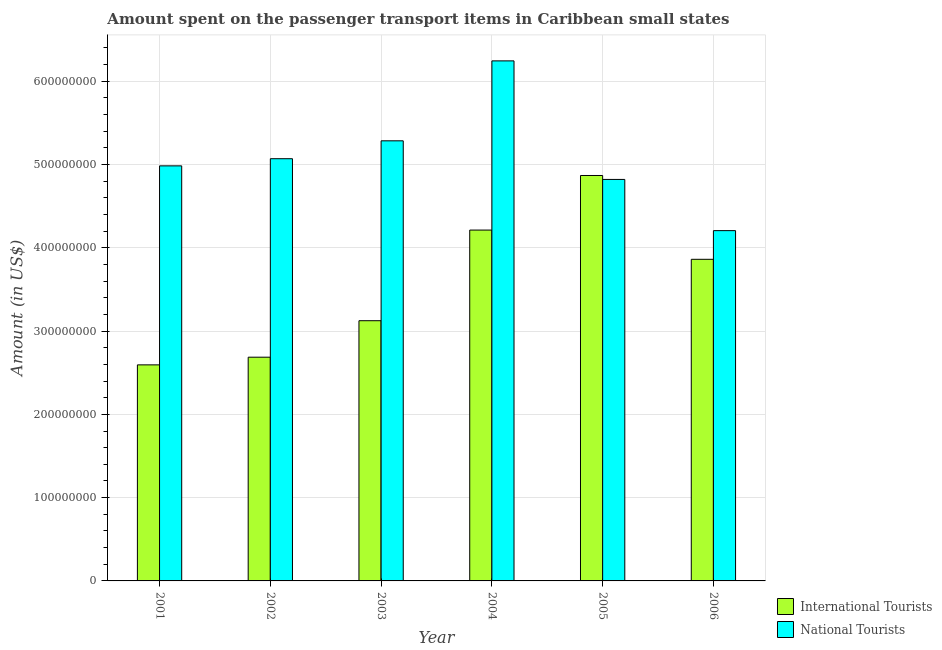Are the number of bars per tick equal to the number of legend labels?
Your answer should be compact. Yes. How many bars are there on the 6th tick from the right?
Give a very brief answer. 2. What is the label of the 6th group of bars from the left?
Provide a short and direct response. 2006. In how many cases, is the number of bars for a given year not equal to the number of legend labels?
Offer a terse response. 0. What is the amount spent on transport items of international tourists in 2005?
Make the answer very short. 4.87e+08. Across all years, what is the maximum amount spent on transport items of national tourists?
Provide a succinct answer. 6.25e+08. Across all years, what is the minimum amount spent on transport items of international tourists?
Your answer should be very brief. 2.59e+08. In which year was the amount spent on transport items of national tourists minimum?
Make the answer very short. 2006. What is the total amount spent on transport items of international tourists in the graph?
Offer a terse response. 2.14e+09. What is the difference between the amount spent on transport items of national tourists in 2001 and that in 2003?
Provide a succinct answer. -3.01e+07. What is the difference between the amount spent on transport items of international tourists in 2003 and the amount spent on transport items of national tourists in 2005?
Offer a terse response. -1.74e+08. What is the average amount spent on transport items of national tourists per year?
Offer a very short reply. 5.10e+08. In the year 2006, what is the difference between the amount spent on transport items of national tourists and amount spent on transport items of international tourists?
Make the answer very short. 0. What is the ratio of the amount spent on transport items of international tourists in 2002 to that in 2005?
Ensure brevity in your answer.  0.55. Is the difference between the amount spent on transport items of international tourists in 2003 and 2005 greater than the difference between the amount spent on transport items of national tourists in 2003 and 2005?
Offer a terse response. No. What is the difference between the highest and the second highest amount spent on transport items of national tourists?
Provide a short and direct response. 9.60e+07. What is the difference between the highest and the lowest amount spent on transport items of national tourists?
Ensure brevity in your answer.  2.04e+08. Is the sum of the amount spent on transport items of international tourists in 2001 and 2006 greater than the maximum amount spent on transport items of national tourists across all years?
Keep it short and to the point. Yes. What does the 2nd bar from the left in 2004 represents?
Provide a short and direct response. National Tourists. What does the 2nd bar from the right in 2003 represents?
Provide a succinct answer. International Tourists. How many bars are there?
Your response must be concise. 12. Are all the bars in the graph horizontal?
Your answer should be very brief. No. What is the difference between two consecutive major ticks on the Y-axis?
Your answer should be compact. 1.00e+08. Does the graph contain any zero values?
Provide a succinct answer. No. Where does the legend appear in the graph?
Offer a terse response. Bottom right. What is the title of the graph?
Offer a very short reply. Amount spent on the passenger transport items in Caribbean small states. What is the label or title of the X-axis?
Give a very brief answer. Year. What is the Amount (in US$) of International Tourists in 2001?
Offer a very short reply. 2.59e+08. What is the Amount (in US$) in National Tourists in 2001?
Offer a terse response. 4.98e+08. What is the Amount (in US$) of International Tourists in 2002?
Offer a terse response. 2.69e+08. What is the Amount (in US$) of National Tourists in 2002?
Ensure brevity in your answer.  5.07e+08. What is the Amount (in US$) of International Tourists in 2003?
Your answer should be very brief. 3.12e+08. What is the Amount (in US$) of National Tourists in 2003?
Give a very brief answer. 5.29e+08. What is the Amount (in US$) of International Tourists in 2004?
Keep it short and to the point. 4.21e+08. What is the Amount (in US$) of National Tourists in 2004?
Offer a terse response. 6.25e+08. What is the Amount (in US$) in International Tourists in 2005?
Your response must be concise. 4.87e+08. What is the Amount (in US$) in National Tourists in 2005?
Offer a very short reply. 4.82e+08. What is the Amount (in US$) in International Tourists in 2006?
Give a very brief answer. 3.86e+08. What is the Amount (in US$) in National Tourists in 2006?
Your answer should be very brief. 4.21e+08. Across all years, what is the maximum Amount (in US$) of International Tourists?
Your answer should be compact. 4.87e+08. Across all years, what is the maximum Amount (in US$) of National Tourists?
Make the answer very short. 6.25e+08. Across all years, what is the minimum Amount (in US$) in International Tourists?
Offer a terse response. 2.59e+08. Across all years, what is the minimum Amount (in US$) of National Tourists?
Ensure brevity in your answer.  4.21e+08. What is the total Amount (in US$) of International Tourists in the graph?
Offer a terse response. 2.14e+09. What is the total Amount (in US$) of National Tourists in the graph?
Your answer should be compact. 3.06e+09. What is the difference between the Amount (in US$) in International Tourists in 2001 and that in 2002?
Offer a very short reply. -9.22e+06. What is the difference between the Amount (in US$) of National Tourists in 2001 and that in 2002?
Your answer should be very brief. -8.59e+06. What is the difference between the Amount (in US$) of International Tourists in 2001 and that in 2003?
Make the answer very short. -5.30e+07. What is the difference between the Amount (in US$) in National Tourists in 2001 and that in 2003?
Make the answer very short. -3.01e+07. What is the difference between the Amount (in US$) of International Tourists in 2001 and that in 2004?
Your answer should be compact. -1.62e+08. What is the difference between the Amount (in US$) of National Tourists in 2001 and that in 2004?
Your answer should be very brief. -1.26e+08. What is the difference between the Amount (in US$) of International Tourists in 2001 and that in 2005?
Your response must be concise. -2.27e+08. What is the difference between the Amount (in US$) in National Tourists in 2001 and that in 2005?
Your answer should be compact. 1.63e+07. What is the difference between the Amount (in US$) of International Tourists in 2001 and that in 2006?
Give a very brief answer. -1.27e+08. What is the difference between the Amount (in US$) of National Tourists in 2001 and that in 2006?
Your response must be concise. 7.78e+07. What is the difference between the Amount (in US$) of International Tourists in 2002 and that in 2003?
Provide a succinct answer. -4.38e+07. What is the difference between the Amount (in US$) of National Tourists in 2002 and that in 2003?
Provide a short and direct response. -2.15e+07. What is the difference between the Amount (in US$) in International Tourists in 2002 and that in 2004?
Give a very brief answer. -1.53e+08. What is the difference between the Amount (in US$) in National Tourists in 2002 and that in 2004?
Your answer should be compact. -1.17e+08. What is the difference between the Amount (in US$) in International Tourists in 2002 and that in 2005?
Provide a succinct answer. -2.18e+08. What is the difference between the Amount (in US$) in National Tourists in 2002 and that in 2005?
Give a very brief answer. 2.49e+07. What is the difference between the Amount (in US$) of International Tourists in 2002 and that in 2006?
Your answer should be very brief. -1.18e+08. What is the difference between the Amount (in US$) of National Tourists in 2002 and that in 2006?
Give a very brief answer. 8.64e+07. What is the difference between the Amount (in US$) in International Tourists in 2003 and that in 2004?
Offer a terse response. -1.09e+08. What is the difference between the Amount (in US$) of National Tourists in 2003 and that in 2004?
Offer a very short reply. -9.60e+07. What is the difference between the Amount (in US$) in International Tourists in 2003 and that in 2005?
Provide a short and direct response. -1.74e+08. What is the difference between the Amount (in US$) in National Tourists in 2003 and that in 2005?
Your answer should be compact. 4.64e+07. What is the difference between the Amount (in US$) in International Tourists in 2003 and that in 2006?
Your answer should be very brief. -7.37e+07. What is the difference between the Amount (in US$) in National Tourists in 2003 and that in 2006?
Give a very brief answer. 1.08e+08. What is the difference between the Amount (in US$) in International Tourists in 2004 and that in 2005?
Your answer should be very brief. -6.55e+07. What is the difference between the Amount (in US$) in National Tourists in 2004 and that in 2005?
Provide a succinct answer. 1.42e+08. What is the difference between the Amount (in US$) of International Tourists in 2004 and that in 2006?
Keep it short and to the point. 3.51e+07. What is the difference between the Amount (in US$) of National Tourists in 2004 and that in 2006?
Provide a short and direct response. 2.04e+08. What is the difference between the Amount (in US$) in International Tourists in 2005 and that in 2006?
Provide a short and direct response. 1.01e+08. What is the difference between the Amount (in US$) in National Tourists in 2005 and that in 2006?
Make the answer very short. 6.15e+07. What is the difference between the Amount (in US$) of International Tourists in 2001 and the Amount (in US$) of National Tourists in 2002?
Provide a short and direct response. -2.48e+08. What is the difference between the Amount (in US$) of International Tourists in 2001 and the Amount (in US$) of National Tourists in 2003?
Your answer should be compact. -2.69e+08. What is the difference between the Amount (in US$) of International Tourists in 2001 and the Amount (in US$) of National Tourists in 2004?
Make the answer very short. -3.65e+08. What is the difference between the Amount (in US$) of International Tourists in 2001 and the Amount (in US$) of National Tourists in 2005?
Your answer should be compact. -2.23e+08. What is the difference between the Amount (in US$) in International Tourists in 2001 and the Amount (in US$) in National Tourists in 2006?
Your response must be concise. -1.61e+08. What is the difference between the Amount (in US$) in International Tourists in 2002 and the Amount (in US$) in National Tourists in 2003?
Offer a very short reply. -2.60e+08. What is the difference between the Amount (in US$) in International Tourists in 2002 and the Amount (in US$) in National Tourists in 2004?
Offer a terse response. -3.56e+08. What is the difference between the Amount (in US$) of International Tourists in 2002 and the Amount (in US$) of National Tourists in 2005?
Keep it short and to the point. -2.13e+08. What is the difference between the Amount (in US$) in International Tourists in 2002 and the Amount (in US$) in National Tourists in 2006?
Give a very brief answer. -1.52e+08. What is the difference between the Amount (in US$) of International Tourists in 2003 and the Amount (in US$) of National Tourists in 2004?
Provide a short and direct response. -3.12e+08. What is the difference between the Amount (in US$) of International Tourists in 2003 and the Amount (in US$) of National Tourists in 2005?
Offer a very short reply. -1.70e+08. What is the difference between the Amount (in US$) of International Tourists in 2003 and the Amount (in US$) of National Tourists in 2006?
Give a very brief answer. -1.08e+08. What is the difference between the Amount (in US$) in International Tourists in 2004 and the Amount (in US$) in National Tourists in 2005?
Offer a very short reply. -6.08e+07. What is the difference between the Amount (in US$) of International Tourists in 2004 and the Amount (in US$) of National Tourists in 2006?
Provide a short and direct response. 6.79e+05. What is the difference between the Amount (in US$) in International Tourists in 2005 and the Amount (in US$) in National Tourists in 2006?
Your answer should be compact. 6.62e+07. What is the average Amount (in US$) of International Tourists per year?
Your answer should be very brief. 3.56e+08. What is the average Amount (in US$) in National Tourists per year?
Your answer should be compact. 5.10e+08. In the year 2001, what is the difference between the Amount (in US$) of International Tourists and Amount (in US$) of National Tourists?
Provide a short and direct response. -2.39e+08. In the year 2002, what is the difference between the Amount (in US$) of International Tourists and Amount (in US$) of National Tourists?
Offer a terse response. -2.38e+08. In the year 2003, what is the difference between the Amount (in US$) of International Tourists and Amount (in US$) of National Tourists?
Make the answer very short. -2.16e+08. In the year 2004, what is the difference between the Amount (in US$) in International Tourists and Amount (in US$) in National Tourists?
Your answer should be compact. -2.03e+08. In the year 2005, what is the difference between the Amount (in US$) in International Tourists and Amount (in US$) in National Tourists?
Your answer should be compact. 4.74e+06. In the year 2006, what is the difference between the Amount (in US$) in International Tourists and Amount (in US$) in National Tourists?
Make the answer very short. -3.44e+07. What is the ratio of the Amount (in US$) in International Tourists in 2001 to that in 2002?
Your response must be concise. 0.97. What is the ratio of the Amount (in US$) in National Tourists in 2001 to that in 2002?
Offer a very short reply. 0.98. What is the ratio of the Amount (in US$) of International Tourists in 2001 to that in 2003?
Provide a succinct answer. 0.83. What is the ratio of the Amount (in US$) in National Tourists in 2001 to that in 2003?
Provide a succinct answer. 0.94. What is the ratio of the Amount (in US$) in International Tourists in 2001 to that in 2004?
Provide a succinct answer. 0.62. What is the ratio of the Amount (in US$) in National Tourists in 2001 to that in 2004?
Give a very brief answer. 0.8. What is the ratio of the Amount (in US$) in International Tourists in 2001 to that in 2005?
Offer a very short reply. 0.53. What is the ratio of the Amount (in US$) of National Tourists in 2001 to that in 2005?
Provide a succinct answer. 1.03. What is the ratio of the Amount (in US$) of International Tourists in 2001 to that in 2006?
Give a very brief answer. 0.67. What is the ratio of the Amount (in US$) in National Tourists in 2001 to that in 2006?
Make the answer very short. 1.18. What is the ratio of the Amount (in US$) of International Tourists in 2002 to that in 2003?
Your response must be concise. 0.86. What is the ratio of the Amount (in US$) in National Tourists in 2002 to that in 2003?
Keep it short and to the point. 0.96. What is the ratio of the Amount (in US$) of International Tourists in 2002 to that in 2004?
Provide a short and direct response. 0.64. What is the ratio of the Amount (in US$) in National Tourists in 2002 to that in 2004?
Your answer should be compact. 0.81. What is the ratio of the Amount (in US$) in International Tourists in 2002 to that in 2005?
Offer a terse response. 0.55. What is the ratio of the Amount (in US$) of National Tourists in 2002 to that in 2005?
Your answer should be compact. 1.05. What is the ratio of the Amount (in US$) of International Tourists in 2002 to that in 2006?
Ensure brevity in your answer.  0.7. What is the ratio of the Amount (in US$) of National Tourists in 2002 to that in 2006?
Provide a short and direct response. 1.21. What is the ratio of the Amount (in US$) in International Tourists in 2003 to that in 2004?
Your answer should be very brief. 0.74. What is the ratio of the Amount (in US$) of National Tourists in 2003 to that in 2004?
Your answer should be compact. 0.85. What is the ratio of the Amount (in US$) of International Tourists in 2003 to that in 2005?
Your answer should be compact. 0.64. What is the ratio of the Amount (in US$) of National Tourists in 2003 to that in 2005?
Offer a very short reply. 1.1. What is the ratio of the Amount (in US$) of International Tourists in 2003 to that in 2006?
Your response must be concise. 0.81. What is the ratio of the Amount (in US$) in National Tourists in 2003 to that in 2006?
Offer a terse response. 1.26. What is the ratio of the Amount (in US$) of International Tourists in 2004 to that in 2005?
Your answer should be very brief. 0.87. What is the ratio of the Amount (in US$) in National Tourists in 2004 to that in 2005?
Offer a terse response. 1.3. What is the ratio of the Amount (in US$) in International Tourists in 2004 to that in 2006?
Give a very brief answer. 1.09. What is the ratio of the Amount (in US$) of National Tourists in 2004 to that in 2006?
Keep it short and to the point. 1.48. What is the ratio of the Amount (in US$) of International Tourists in 2005 to that in 2006?
Provide a short and direct response. 1.26. What is the ratio of the Amount (in US$) of National Tourists in 2005 to that in 2006?
Your answer should be very brief. 1.15. What is the difference between the highest and the second highest Amount (in US$) of International Tourists?
Keep it short and to the point. 6.55e+07. What is the difference between the highest and the second highest Amount (in US$) in National Tourists?
Ensure brevity in your answer.  9.60e+07. What is the difference between the highest and the lowest Amount (in US$) of International Tourists?
Keep it short and to the point. 2.27e+08. What is the difference between the highest and the lowest Amount (in US$) in National Tourists?
Provide a short and direct response. 2.04e+08. 